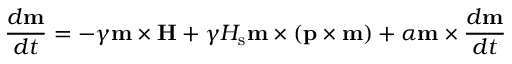Convert formula to latex. <formula><loc_0><loc_0><loc_500><loc_500>\frac { d m } { d t } = - \gamma m \times H + \gamma H _ { s } m \times \left ( p \times m \right ) + \alpha m \times \frac { d m } { d t }</formula> 